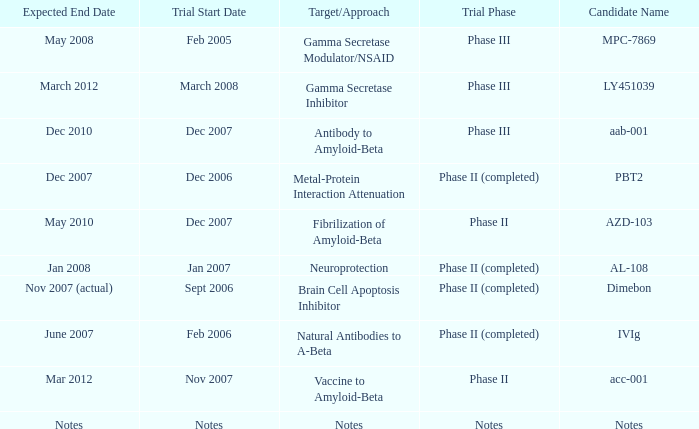What is Expected End Date, when Target/Approach is Notes? Notes. 